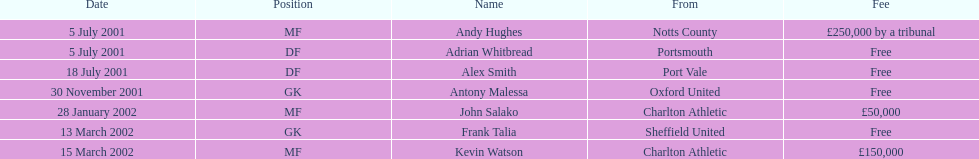Which transfer in was next after john salako's in 2002? Frank Talia. 